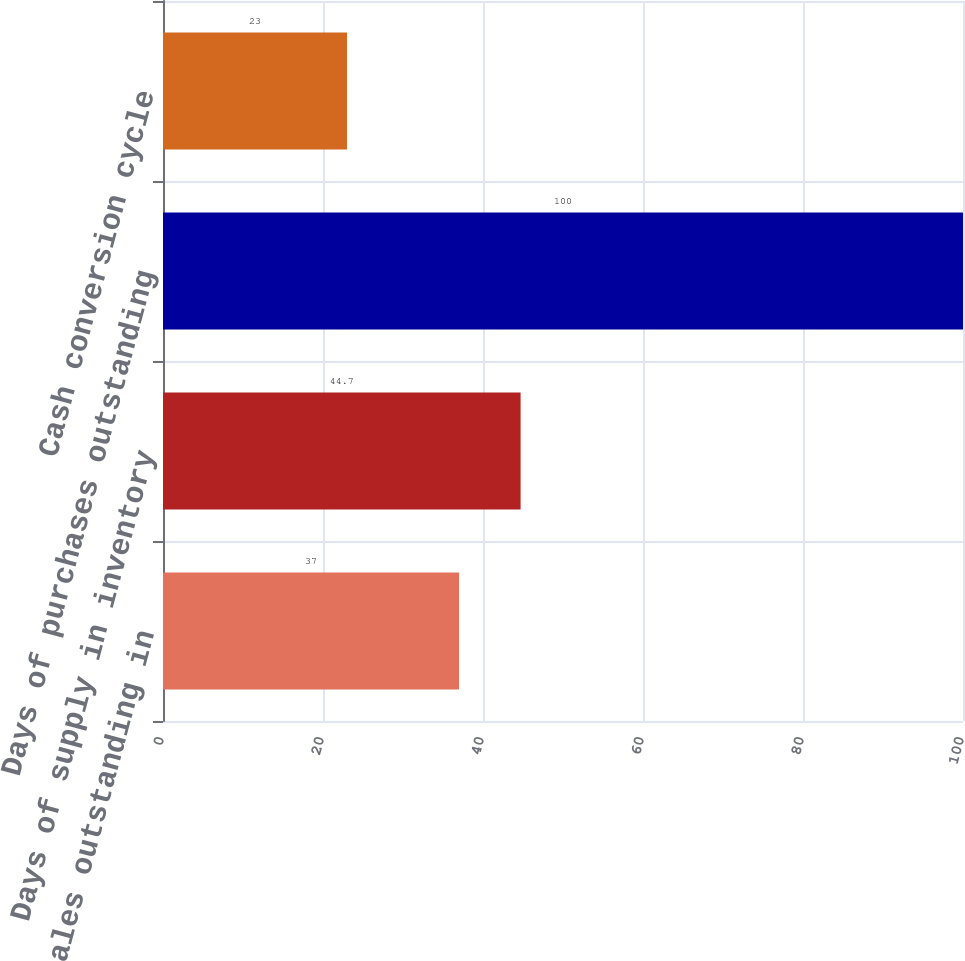Convert chart. <chart><loc_0><loc_0><loc_500><loc_500><bar_chart><fcel>Days of sales outstanding in<fcel>Days of supply in inventory<fcel>Days of purchases outstanding<fcel>Cash conversion cycle<nl><fcel>37<fcel>44.7<fcel>100<fcel>23<nl></chart> 